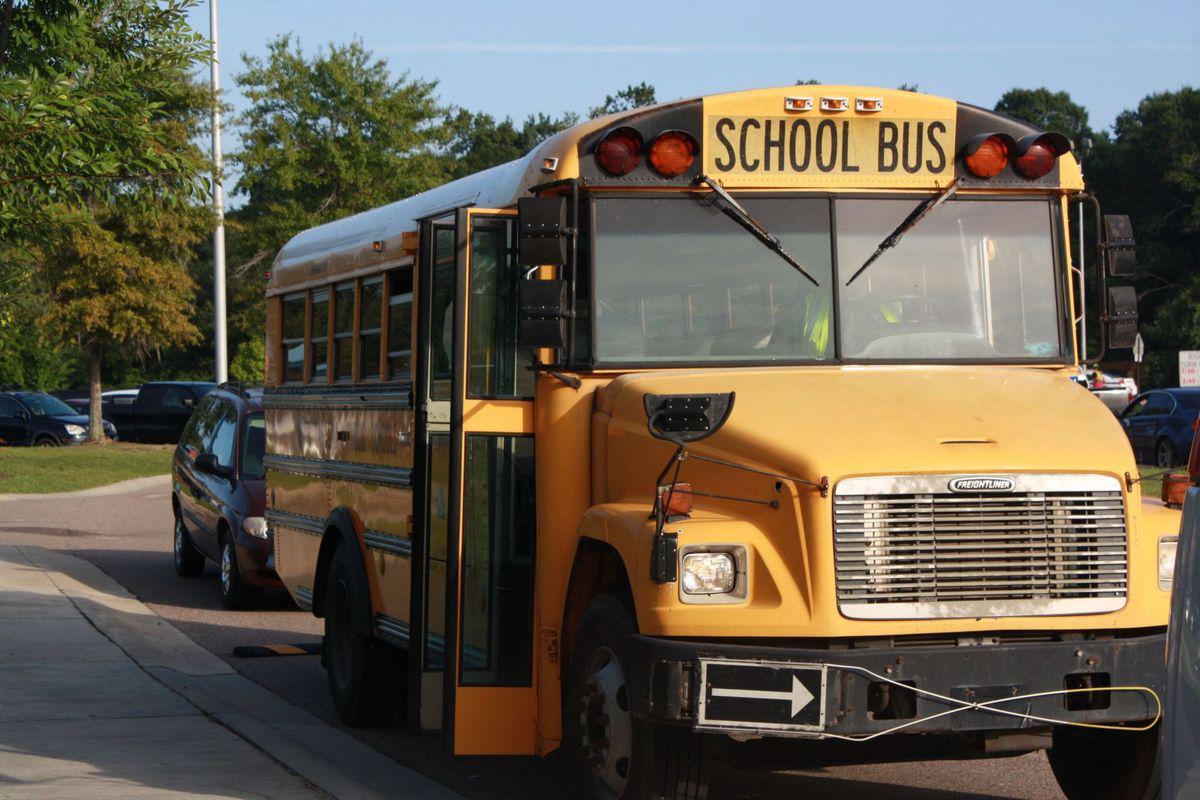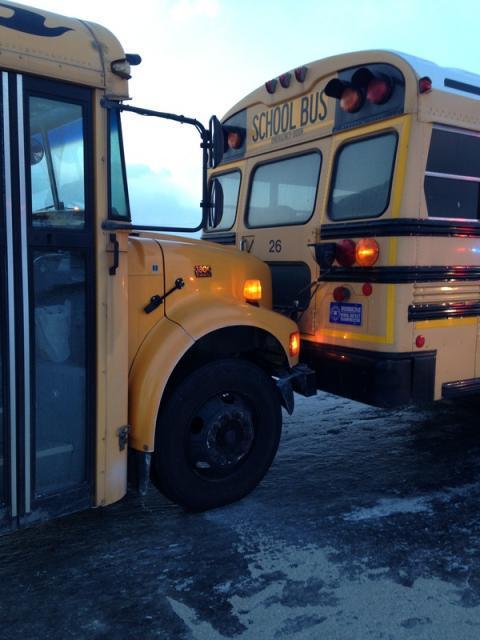The first image is the image on the left, the second image is the image on the right. Assess this claim about the two images: "A white truck is visible in the left image.". Correct or not? Answer yes or no. No. The first image is the image on the left, the second image is the image on the right. Analyze the images presented: Is the assertion "In one of the images you can see firemen tending to an accident between a school bus and a white truck." valid? Answer yes or no. No. 